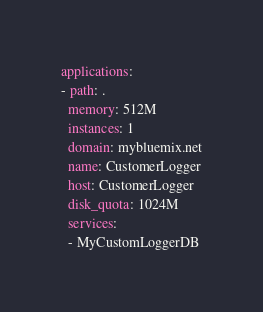<code> <loc_0><loc_0><loc_500><loc_500><_YAML_>applications:
- path: .
  memory: 512M
  instances: 1
  domain: mybluemix.net
  name: CustomerLogger
  host: CustomerLogger
  disk_quota: 1024M
  services:
  - MyCustomLoggerDB</code> 